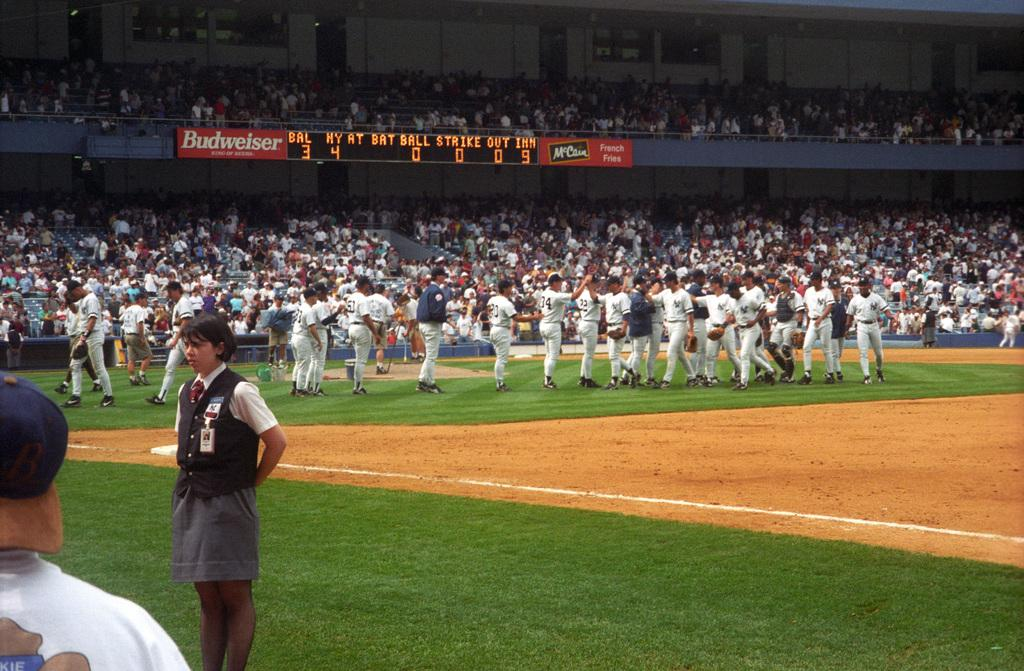Provide a one-sentence caption for the provided image. the Budweiser sign is next to the score board. 